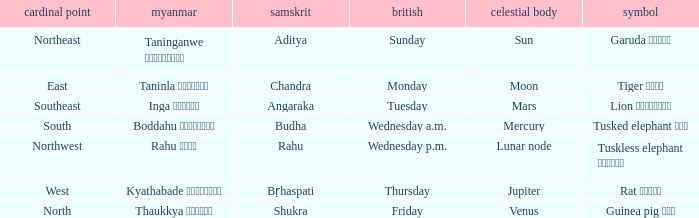What is the planet associated with the direction of south? Mercury. Can you give me this table as a dict? {'header': ['cardinal point', 'myanmar', 'samskrit', 'british', 'celestial body', 'symbol'], 'rows': [['Northeast', 'Taninganwe တနင်္ဂနွေ', 'Aditya', 'Sunday', 'Sun', 'Garuda ဂဠုန်'], ['East', 'Taninla တနင်္လာ', 'Chandra', 'Monday', 'Moon', 'Tiger ကျား'], ['Southeast', 'Inga အင်္ဂါ', 'Angaraka', 'Tuesday', 'Mars', 'Lion ခြင်္သေ့'], ['South', 'Boddahu ဗုဒ္ဓဟူး', 'Budha', 'Wednesday a.m.', 'Mercury', 'Tusked elephant ဆင်'], ['Northwest', 'Rahu ရာဟု', 'Rahu', 'Wednesday p.m.', 'Lunar node', 'Tuskless elephant ဟိုင်း'], ['West', 'Kyathabade ကြာသပတေး', 'Bṛhaspati', 'Thursday', 'Jupiter', 'Rat ကြွက်'], ['North', 'Thaukkya သောကြာ', 'Shukra', 'Friday', 'Venus', 'Guinea pig ပူး']]} 